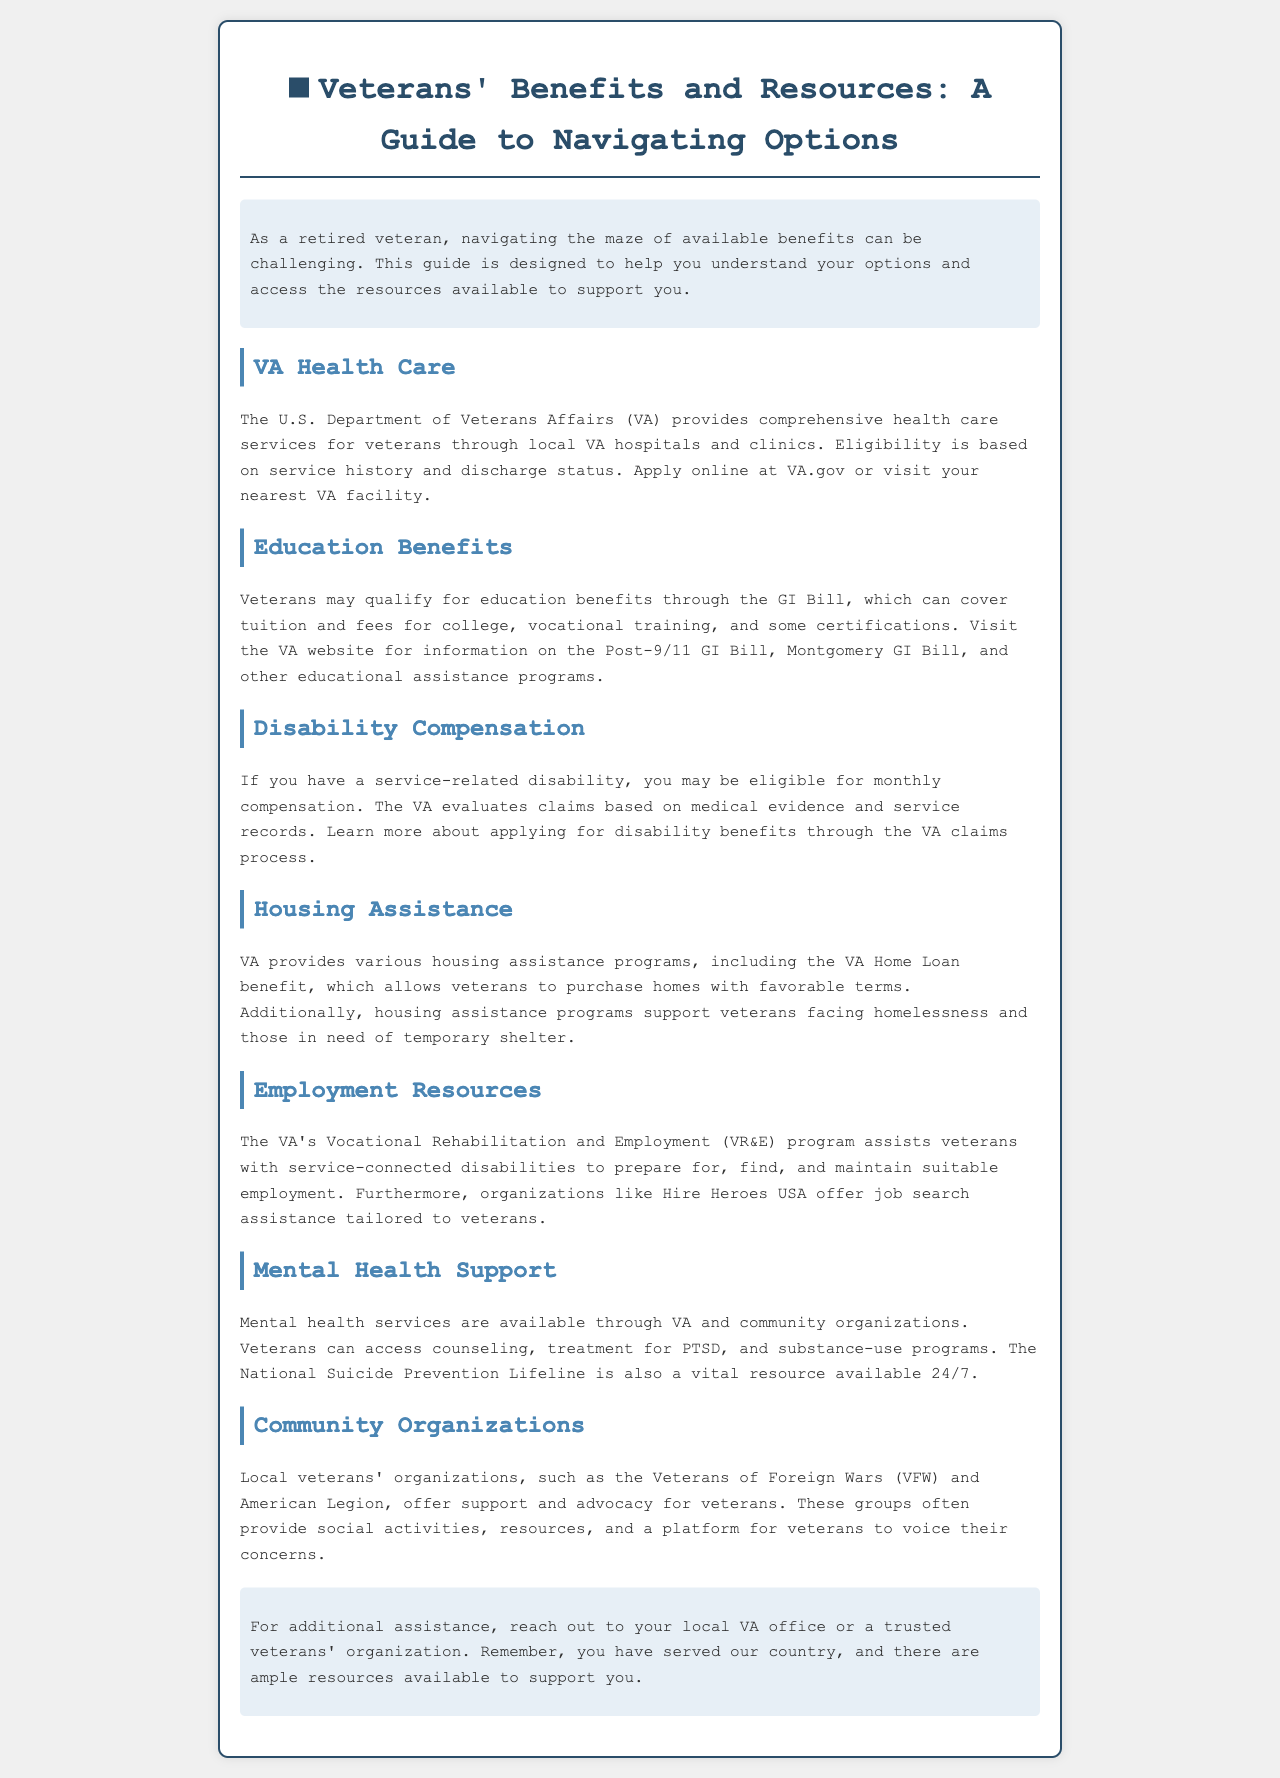What services does the VA provide for veterans? The VA provides comprehensive health care services for veterans through local VA hospitals and clinics.
Answer: health care services What program assists veterans with service-connected disabilities to maintain employment? The Vocational Rehabilitation and Employment (VR&E) program assists veterans with service-connected disabilities to prepare for, find, and maintain suitable employment.
Answer: VR&E program Which bill can cover tuition and fees for college and vocational training? The GI Bill can cover tuition and fees for college, vocational training, and some certifications.
Answer: GI Bill What is one key resource for mental health support mentioned in the brochure? The National Suicide Prevention Lifeline is mentioned as a vital resource for mental health support.
Answer: National Suicide Prevention Lifeline What organization is mentioned that assists with job searches tailored to veterans? Hire Heroes USA is an organization that offers job search assistance tailored to veterans.
Answer: Hire Heroes USA How does someone apply for VA Health Care? Eligibility is based on service history and discharge status; apply online at VA.gov or visit your nearest VA facility.
Answer: VA.gov What are the housing options provided by the VA? VA provides various housing assistance programs, including the VA Home Loan benefit.
Answer: VA Home Loan benefit Which organization offers advocacy for veterans and social activities? Local veterans' organizations, such as the Veterans of Foreign Wars (VFW) and American Legion, offer support and advocacy.
Answer: VFW and American Legion 